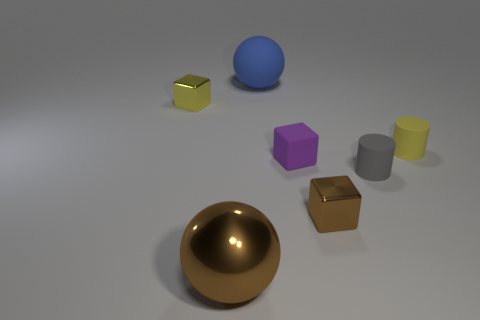What is the shape of the other shiny object that is the same color as the big metal object? cube 